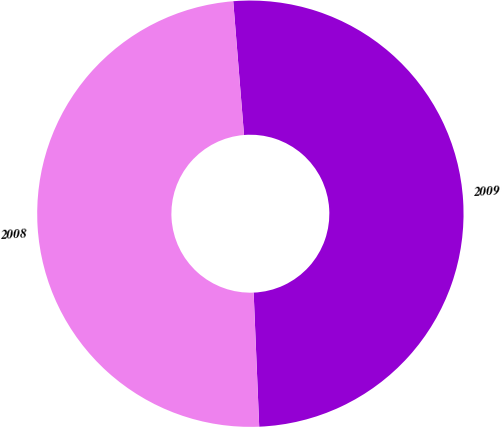Convert chart to OTSL. <chart><loc_0><loc_0><loc_500><loc_500><pie_chart><fcel>2009<fcel>2008<nl><fcel>50.62%<fcel>49.38%<nl></chart> 